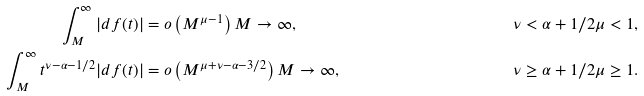<formula> <loc_0><loc_0><loc_500><loc_500>\int _ { M } ^ { \infty } | d f ( t ) | & = o \left ( M ^ { \mu - 1 } \right ) M \to \infty , & \nu < \alpha + 1 / 2 \mu < 1 , \\ \int _ { M } ^ { \infty } t ^ { \nu - \alpha - 1 / 2 } | d f ( t ) | & = o \left ( M ^ { \mu + \nu - \alpha - 3 / 2 } \right ) M \to \infty , & \nu \geq \alpha + 1 / 2 \mu \geq 1 .</formula> 